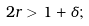Convert formula to latex. <formula><loc_0><loc_0><loc_500><loc_500>2 r > 1 + \delta ;</formula> 